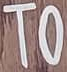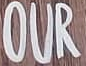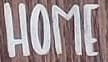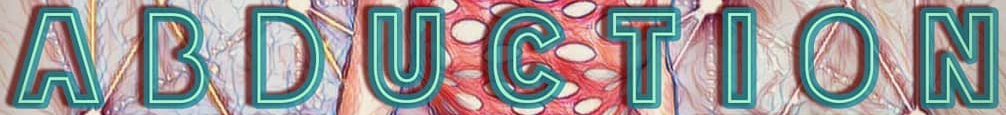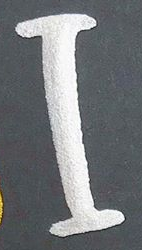Read the text content from these images in order, separated by a semicolon. TO; OUR; HOME; ABDUCTION; I 